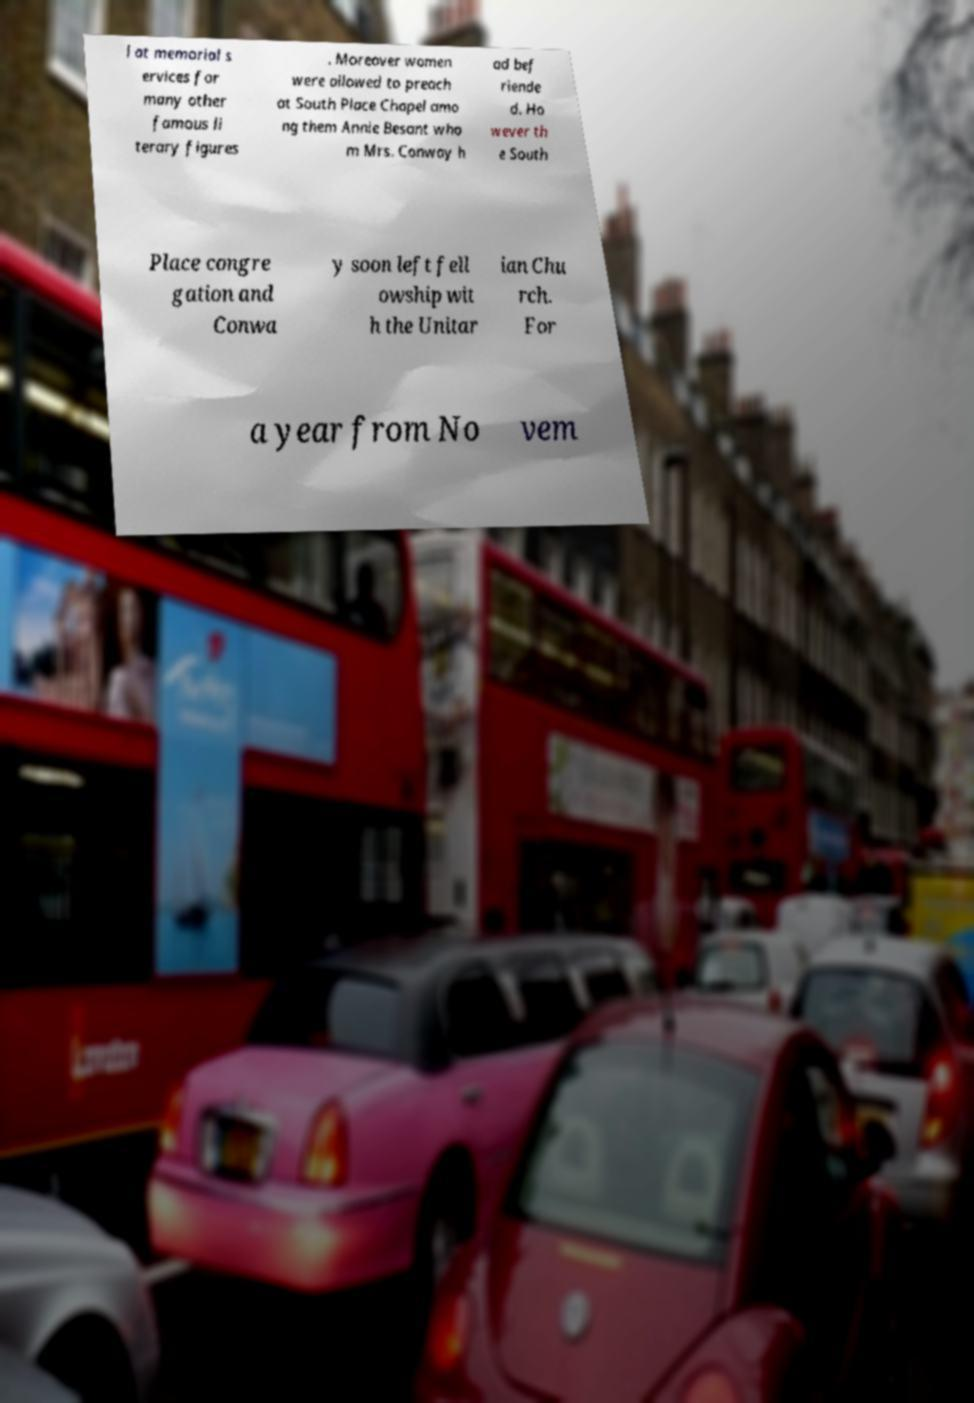What messages or text are displayed in this image? I need them in a readable, typed format. l at memorial s ervices for many other famous li terary figures . Moreover women were allowed to preach at South Place Chapel amo ng them Annie Besant who m Mrs. Conway h ad bef riende d. Ho wever th e South Place congre gation and Conwa y soon left fell owship wit h the Unitar ian Chu rch. For a year from No vem 